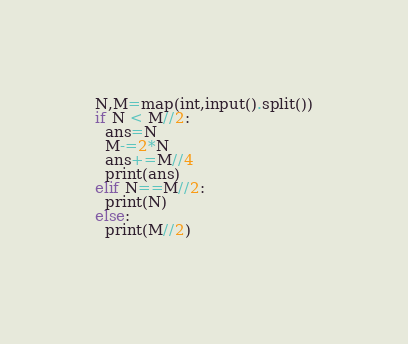<code> <loc_0><loc_0><loc_500><loc_500><_Python_>N,M=map(int,input().split())
if N < M//2:
  ans=N
  M-=2*N
  ans+=M//4
  print(ans)
elif N==M//2:
  print(N)
else:
  print(M//2)
  </code> 